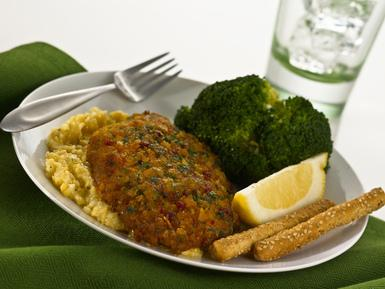Which item on the plate likely is highest in vitamins and minerals? broccoli 